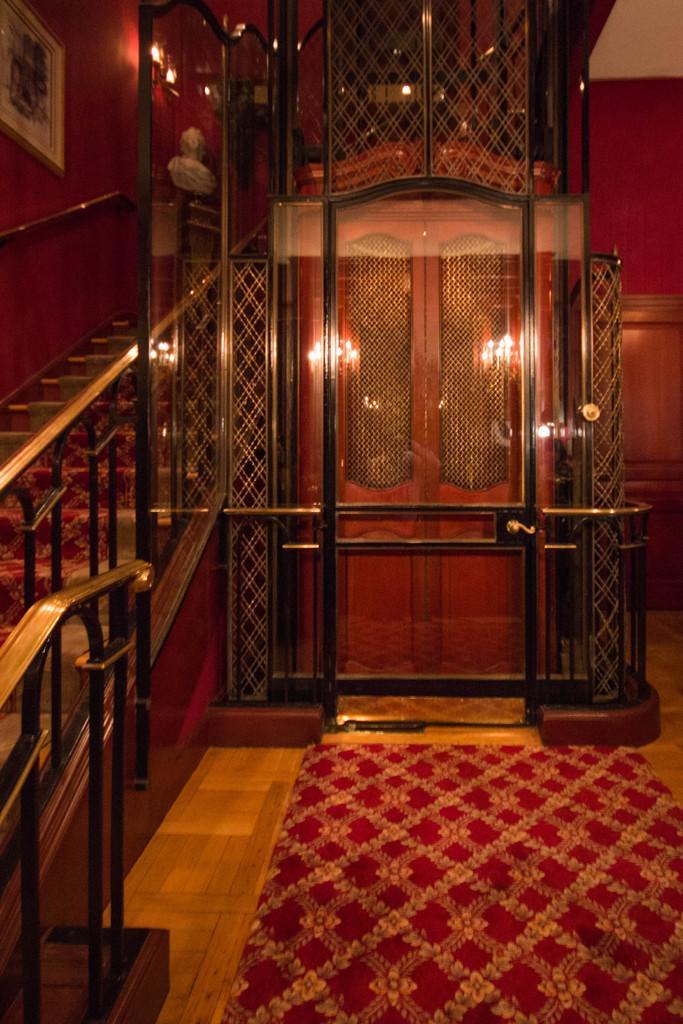Describe this image in one or two sentences. On the left side, there are steps having a fence on both sides. On the right side, there is a mat on a wooden floor. In the background, there are doors and there are lights and a photo frame attached to a wall. 